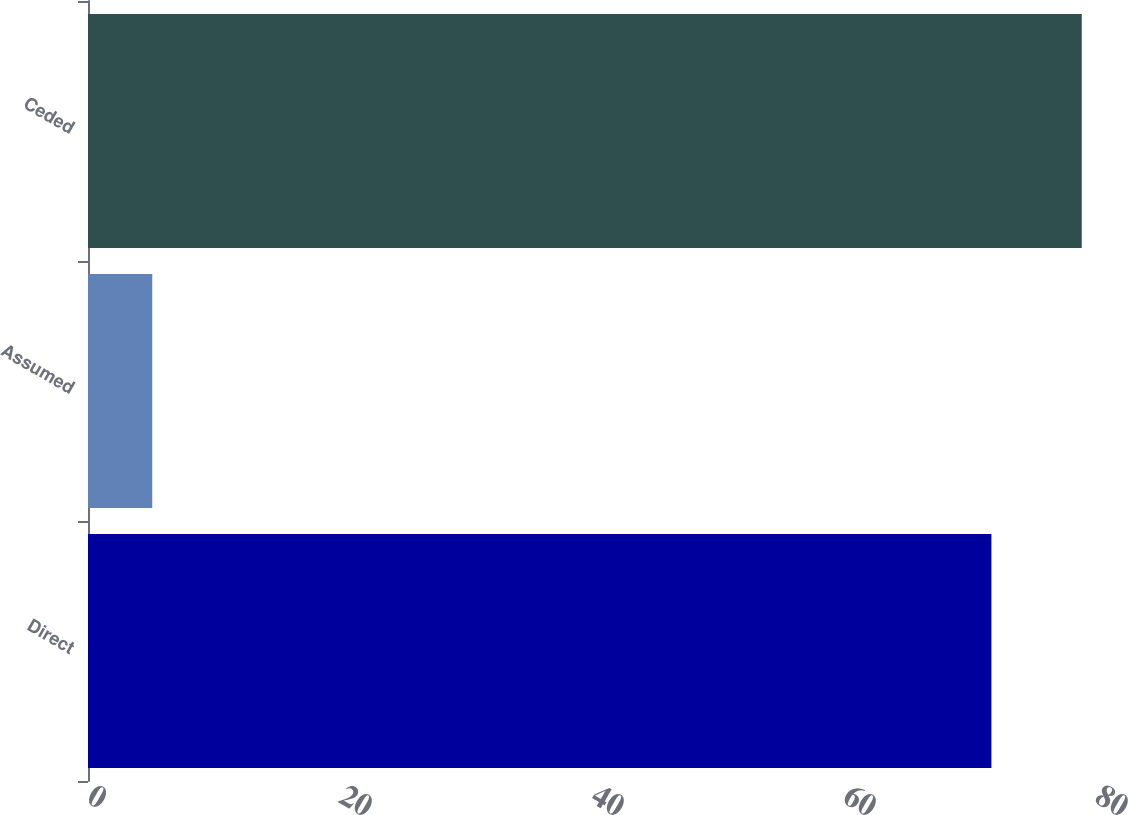Convert chart to OTSL. <chart><loc_0><loc_0><loc_500><loc_500><bar_chart><fcel>Direct<fcel>Assumed<fcel>Ceded<nl><fcel>71.7<fcel>5.1<fcel>78.87<nl></chart> 